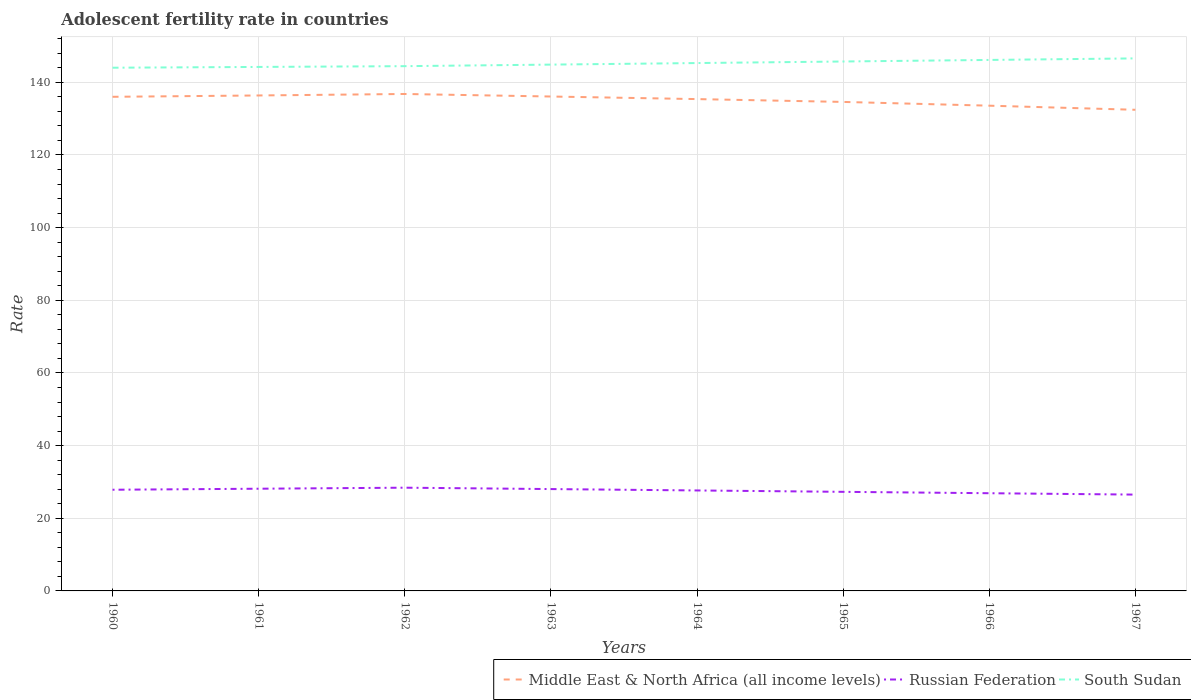How many different coloured lines are there?
Provide a succinct answer. 3. Does the line corresponding to Russian Federation intersect with the line corresponding to South Sudan?
Make the answer very short. No. Across all years, what is the maximum adolescent fertility rate in South Sudan?
Make the answer very short. 144.02. In which year was the adolescent fertility rate in South Sudan maximum?
Provide a short and direct response. 1960. What is the total adolescent fertility rate in Russian Federation in the graph?
Your answer should be compact. 1.52. What is the difference between the highest and the second highest adolescent fertility rate in South Sudan?
Provide a short and direct response. 2.57. What is the difference between the highest and the lowest adolescent fertility rate in South Sudan?
Your answer should be very brief. 4. Is the adolescent fertility rate in Middle East & North Africa (all income levels) strictly greater than the adolescent fertility rate in South Sudan over the years?
Offer a very short reply. Yes. How many lines are there?
Give a very brief answer. 3. What is the difference between two consecutive major ticks on the Y-axis?
Offer a very short reply. 20. Are the values on the major ticks of Y-axis written in scientific E-notation?
Your answer should be compact. No. How many legend labels are there?
Offer a terse response. 3. What is the title of the graph?
Offer a very short reply. Adolescent fertility rate in countries. What is the label or title of the Y-axis?
Offer a very short reply. Rate. What is the Rate of Middle East & North Africa (all income levels) in 1960?
Ensure brevity in your answer.  136.02. What is the Rate of Russian Federation in 1960?
Your answer should be compact. 27.85. What is the Rate in South Sudan in 1960?
Provide a succinct answer. 144.02. What is the Rate of Middle East & North Africa (all income levels) in 1961?
Ensure brevity in your answer.  136.38. What is the Rate in Russian Federation in 1961?
Provide a succinct answer. 28.13. What is the Rate of South Sudan in 1961?
Provide a succinct answer. 144.24. What is the Rate in Middle East & North Africa (all income levels) in 1962?
Your response must be concise. 136.79. What is the Rate of Russian Federation in 1962?
Offer a very short reply. 28.42. What is the Rate in South Sudan in 1962?
Your answer should be compact. 144.45. What is the Rate in Middle East & North Africa (all income levels) in 1963?
Provide a succinct answer. 136.1. What is the Rate of Russian Federation in 1963?
Offer a very short reply. 28.04. What is the Rate in South Sudan in 1963?
Give a very brief answer. 144.88. What is the Rate in Middle East & North Africa (all income levels) in 1964?
Give a very brief answer. 135.38. What is the Rate of Russian Federation in 1964?
Provide a short and direct response. 27.66. What is the Rate of South Sudan in 1964?
Offer a very short reply. 145.31. What is the Rate of Middle East & North Africa (all income levels) in 1965?
Your response must be concise. 134.61. What is the Rate in Russian Federation in 1965?
Keep it short and to the point. 27.28. What is the Rate in South Sudan in 1965?
Offer a very short reply. 145.73. What is the Rate in Middle East & North Africa (all income levels) in 1966?
Provide a short and direct response. 133.57. What is the Rate of Russian Federation in 1966?
Give a very brief answer. 26.89. What is the Rate of South Sudan in 1966?
Your response must be concise. 146.16. What is the Rate of Middle East & North Africa (all income levels) in 1967?
Offer a terse response. 132.44. What is the Rate in Russian Federation in 1967?
Your answer should be very brief. 26.51. What is the Rate of South Sudan in 1967?
Offer a very short reply. 146.59. Across all years, what is the maximum Rate of Middle East & North Africa (all income levels)?
Provide a succinct answer. 136.79. Across all years, what is the maximum Rate of Russian Federation?
Ensure brevity in your answer.  28.42. Across all years, what is the maximum Rate in South Sudan?
Keep it short and to the point. 146.59. Across all years, what is the minimum Rate of Middle East & North Africa (all income levels)?
Your response must be concise. 132.44. Across all years, what is the minimum Rate in Russian Federation?
Ensure brevity in your answer.  26.51. Across all years, what is the minimum Rate in South Sudan?
Give a very brief answer. 144.02. What is the total Rate in Middle East & North Africa (all income levels) in the graph?
Your answer should be compact. 1081.29. What is the total Rate of Russian Federation in the graph?
Make the answer very short. 220.78. What is the total Rate in South Sudan in the graph?
Your answer should be very brief. 1161.38. What is the difference between the Rate in Middle East & North Africa (all income levels) in 1960 and that in 1961?
Give a very brief answer. -0.37. What is the difference between the Rate of Russian Federation in 1960 and that in 1961?
Your answer should be very brief. -0.28. What is the difference between the Rate of South Sudan in 1960 and that in 1961?
Your response must be concise. -0.21. What is the difference between the Rate in Middle East & North Africa (all income levels) in 1960 and that in 1962?
Offer a terse response. -0.78. What is the difference between the Rate of Russian Federation in 1960 and that in 1962?
Provide a succinct answer. -0.57. What is the difference between the Rate of South Sudan in 1960 and that in 1962?
Offer a terse response. -0.43. What is the difference between the Rate of Middle East & North Africa (all income levels) in 1960 and that in 1963?
Give a very brief answer. -0.08. What is the difference between the Rate in Russian Federation in 1960 and that in 1963?
Ensure brevity in your answer.  -0.18. What is the difference between the Rate of South Sudan in 1960 and that in 1963?
Your answer should be compact. -0.86. What is the difference between the Rate of Middle East & North Africa (all income levels) in 1960 and that in 1964?
Your response must be concise. 0.63. What is the difference between the Rate of Russian Federation in 1960 and that in 1964?
Your response must be concise. 0.2. What is the difference between the Rate of South Sudan in 1960 and that in 1964?
Provide a succinct answer. -1.28. What is the difference between the Rate of Middle East & North Africa (all income levels) in 1960 and that in 1965?
Provide a short and direct response. 1.41. What is the difference between the Rate of Russian Federation in 1960 and that in 1965?
Provide a short and direct response. 0.58. What is the difference between the Rate in South Sudan in 1960 and that in 1965?
Offer a very short reply. -1.71. What is the difference between the Rate of Middle East & North Africa (all income levels) in 1960 and that in 1966?
Provide a short and direct response. 2.44. What is the difference between the Rate in Russian Federation in 1960 and that in 1966?
Ensure brevity in your answer.  0.96. What is the difference between the Rate in South Sudan in 1960 and that in 1966?
Your answer should be very brief. -2.14. What is the difference between the Rate of Middle East & North Africa (all income levels) in 1960 and that in 1967?
Provide a succinct answer. 3.58. What is the difference between the Rate of Russian Federation in 1960 and that in 1967?
Ensure brevity in your answer.  1.34. What is the difference between the Rate in South Sudan in 1960 and that in 1967?
Provide a succinct answer. -2.57. What is the difference between the Rate in Middle East & North Africa (all income levels) in 1961 and that in 1962?
Your answer should be very brief. -0.41. What is the difference between the Rate of Russian Federation in 1961 and that in 1962?
Give a very brief answer. -0.28. What is the difference between the Rate in South Sudan in 1961 and that in 1962?
Ensure brevity in your answer.  -0.21. What is the difference between the Rate in Middle East & North Africa (all income levels) in 1961 and that in 1963?
Give a very brief answer. 0.29. What is the difference between the Rate of Russian Federation in 1961 and that in 1963?
Make the answer very short. 0.1. What is the difference between the Rate of South Sudan in 1961 and that in 1963?
Your answer should be very brief. -0.64. What is the difference between the Rate in Russian Federation in 1961 and that in 1964?
Keep it short and to the point. 0.48. What is the difference between the Rate in South Sudan in 1961 and that in 1964?
Offer a terse response. -1.07. What is the difference between the Rate of Middle East & North Africa (all income levels) in 1961 and that in 1965?
Make the answer very short. 1.78. What is the difference between the Rate of Russian Federation in 1961 and that in 1965?
Your response must be concise. 0.86. What is the difference between the Rate of South Sudan in 1961 and that in 1965?
Your response must be concise. -1.5. What is the difference between the Rate of Middle East & North Africa (all income levels) in 1961 and that in 1966?
Offer a terse response. 2.81. What is the difference between the Rate of Russian Federation in 1961 and that in 1966?
Offer a very short reply. 1.24. What is the difference between the Rate in South Sudan in 1961 and that in 1966?
Your answer should be compact. -1.93. What is the difference between the Rate in Middle East & North Africa (all income levels) in 1961 and that in 1967?
Give a very brief answer. 3.94. What is the difference between the Rate in Russian Federation in 1961 and that in 1967?
Give a very brief answer. 1.62. What is the difference between the Rate in South Sudan in 1961 and that in 1967?
Keep it short and to the point. -2.35. What is the difference between the Rate of Middle East & North Africa (all income levels) in 1962 and that in 1963?
Offer a very short reply. 0.7. What is the difference between the Rate in Russian Federation in 1962 and that in 1963?
Make the answer very short. 0.38. What is the difference between the Rate in South Sudan in 1962 and that in 1963?
Keep it short and to the point. -0.43. What is the difference between the Rate of Middle East & North Africa (all income levels) in 1962 and that in 1964?
Your response must be concise. 1.41. What is the difference between the Rate of Russian Federation in 1962 and that in 1964?
Ensure brevity in your answer.  0.76. What is the difference between the Rate of South Sudan in 1962 and that in 1964?
Your answer should be very brief. -0.86. What is the difference between the Rate of Middle East & North Africa (all income levels) in 1962 and that in 1965?
Give a very brief answer. 2.18. What is the difference between the Rate in Russian Federation in 1962 and that in 1965?
Make the answer very short. 1.14. What is the difference between the Rate in South Sudan in 1962 and that in 1965?
Offer a terse response. -1.28. What is the difference between the Rate of Middle East & North Africa (all income levels) in 1962 and that in 1966?
Keep it short and to the point. 3.22. What is the difference between the Rate in Russian Federation in 1962 and that in 1966?
Give a very brief answer. 1.52. What is the difference between the Rate of South Sudan in 1962 and that in 1966?
Keep it short and to the point. -1.71. What is the difference between the Rate of Middle East & North Africa (all income levels) in 1962 and that in 1967?
Your response must be concise. 4.35. What is the difference between the Rate of Russian Federation in 1962 and that in 1967?
Provide a short and direct response. 1.9. What is the difference between the Rate of South Sudan in 1962 and that in 1967?
Provide a short and direct response. -2.14. What is the difference between the Rate in Middle East & North Africa (all income levels) in 1963 and that in 1964?
Ensure brevity in your answer.  0.71. What is the difference between the Rate of Russian Federation in 1963 and that in 1964?
Offer a terse response. 0.38. What is the difference between the Rate of South Sudan in 1963 and that in 1964?
Your answer should be compact. -0.43. What is the difference between the Rate in Middle East & North Africa (all income levels) in 1963 and that in 1965?
Your response must be concise. 1.49. What is the difference between the Rate of Russian Federation in 1963 and that in 1965?
Offer a terse response. 0.76. What is the difference between the Rate in South Sudan in 1963 and that in 1965?
Offer a very short reply. -0.86. What is the difference between the Rate of Middle East & North Africa (all income levels) in 1963 and that in 1966?
Your answer should be very brief. 2.52. What is the difference between the Rate of Russian Federation in 1963 and that in 1966?
Your answer should be very brief. 1.14. What is the difference between the Rate of South Sudan in 1963 and that in 1966?
Provide a succinct answer. -1.28. What is the difference between the Rate of Middle East & North Africa (all income levels) in 1963 and that in 1967?
Offer a very short reply. 3.65. What is the difference between the Rate of Russian Federation in 1963 and that in 1967?
Your response must be concise. 1.52. What is the difference between the Rate of South Sudan in 1963 and that in 1967?
Provide a short and direct response. -1.71. What is the difference between the Rate in Middle East & North Africa (all income levels) in 1964 and that in 1965?
Provide a succinct answer. 0.78. What is the difference between the Rate in Russian Federation in 1964 and that in 1965?
Make the answer very short. 0.38. What is the difference between the Rate in South Sudan in 1964 and that in 1965?
Your response must be concise. -0.43. What is the difference between the Rate of Middle East & North Africa (all income levels) in 1964 and that in 1966?
Give a very brief answer. 1.81. What is the difference between the Rate in Russian Federation in 1964 and that in 1966?
Your response must be concise. 0.76. What is the difference between the Rate of South Sudan in 1964 and that in 1966?
Ensure brevity in your answer.  -0.86. What is the difference between the Rate of Middle East & North Africa (all income levels) in 1964 and that in 1967?
Your answer should be very brief. 2.94. What is the difference between the Rate in Russian Federation in 1964 and that in 1967?
Provide a short and direct response. 1.14. What is the difference between the Rate in South Sudan in 1964 and that in 1967?
Provide a short and direct response. -1.28. What is the difference between the Rate in Middle East & North Africa (all income levels) in 1965 and that in 1966?
Keep it short and to the point. 1.04. What is the difference between the Rate of Russian Federation in 1965 and that in 1966?
Offer a very short reply. 0.38. What is the difference between the Rate in South Sudan in 1965 and that in 1966?
Your answer should be very brief. -0.43. What is the difference between the Rate of Middle East & North Africa (all income levels) in 1965 and that in 1967?
Offer a terse response. 2.17. What is the difference between the Rate of Russian Federation in 1965 and that in 1967?
Make the answer very short. 0.76. What is the difference between the Rate in South Sudan in 1965 and that in 1967?
Offer a very short reply. -0.86. What is the difference between the Rate of Middle East & North Africa (all income levels) in 1966 and that in 1967?
Your answer should be compact. 1.13. What is the difference between the Rate of Russian Federation in 1966 and that in 1967?
Your response must be concise. 0.38. What is the difference between the Rate of South Sudan in 1966 and that in 1967?
Your answer should be compact. -0.43. What is the difference between the Rate in Middle East & North Africa (all income levels) in 1960 and the Rate in Russian Federation in 1961?
Your answer should be very brief. 107.88. What is the difference between the Rate in Middle East & North Africa (all income levels) in 1960 and the Rate in South Sudan in 1961?
Your answer should be very brief. -8.22. What is the difference between the Rate in Russian Federation in 1960 and the Rate in South Sudan in 1961?
Ensure brevity in your answer.  -116.38. What is the difference between the Rate in Middle East & North Africa (all income levels) in 1960 and the Rate in Russian Federation in 1962?
Your answer should be compact. 107.6. What is the difference between the Rate in Middle East & North Africa (all income levels) in 1960 and the Rate in South Sudan in 1962?
Offer a very short reply. -8.43. What is the difference between the Rate of Russian Federation in 1960 and the Rate of South Sudan in 1962?
Give a very brief answer. -116.6. What is the difference between the Rate in Middle East & North Africa (all income levels) in 1960 and the Rate in Russian Federation in 1963?
Offer a very short reply. 107.98. What is the difference between the Rate in Middle East & North Africa (all income levels) in 1960 and the Rate in South Sudan in 1963?
Provide a short and direct response. -8.86. What is the difference between the Rate in Russian Federation in 1960 and the Rate in South Sudan in 1963?
Ensure brevity in your answer.  -117.03. What is the difference between the Rate in Middle East & North Africa (all income levels) in 1960 and the Rate in Russian Federation in 1964?
Offer a very short reply. 108.36. What is the difference between the Rate of Middle East & North Africa (all income levels) in 1960 and the Rate of South Sudan in 1964?
Offer a very short reply. -9.29. What is the difference between the Rate in Russian Federation in 1960 and the Rate in South Sudan in 1964?
Provide a succinct answer. -117.45. What is the difference between the Rate in Middle East & North Africa (all income levels) in 1960 and the Rate in Russian Federation in 1965?
Offer a very short reply. 108.74. What is the difference between the Rate in Middle East & North Africa (all income levels) in 1960 and the Rate in South Sudan in 1965?
Keep it short and to the point. -9.72. What is the difference between the Rate in Russian Federation in 1960 and the Rate in South Sudan in 1965?
Provide a short and direct response. -117.88. What is the difference between the Rate in Middle East & North Africa (all income levels) in 1960 and the Rate in Russian Federation in 1966?
Give a very brief answer. 109.12. What is the difference between the Rate of Middle East & North Africa (all income levels) in 1960 and the Rate of South Sudan in 1966?
Keep it short and to the point. -10.15. What is the difference between the Rate in Russian Federation in 1960 and the Rate in South Sudan in 1966?
Offer a terse response. -118.31. What is the difference between the Rate in Middle East & North Africa (all income levels) in 1960 and the Rate in Russian Federation in 1967?
Provide a short and direct response. 109.5. What is the difference between the Rate in Middle East & North Africa (all income levels) in 1960 and the Rate in South Sudan in 1967?
Keep it short and to the point. -10.57. What is the difference between the Rate of Russian Federation in 1960 and the Rate of South Sudan in 1967?
Make the answer very short. -118.74. What is the difference between the Rate of Middle East & North Africa (all income levels) in 1961 and the Rate of Russian Federation in 1962?
Make the answer very short. 107.97. What is the difference between the Rate in Middle East & North Africa (all income levels) in 1961 and the Rate in South Sudan in 1962?
Keep it short and to the point. -8.07. What is the difference between the Rate in Russian Federation in 1961 and the Rate in South Sudan in 1962?
Give a very brief answer. -116.32. What is the difference between the Rate of Middle East & North Africa (all income levels) in 1961 and the Rate of Russian Federation in 1963?
Your answer should be very brief. 108.35. What is the difference between the Rate in Middle East & North Africa (all income levels) in 1961 and the Rate in South Sudan in 1963?
Provide a short and direct response. -8.49. What is the difference between the Rate in Russian Federation in 1961 and the Rate in South Sudan in 1963?
Your answer should be compact. -116.74. What is the difference between the Rate of Middle East & North Africa (all income levels) in 1961 and the Rate of Russian Federation in 1964?
Offer a very short reply. 108.73. What is the difference between the Rate in Middle East & North Africa (all income levels) in 1961 and the Rate in South Sudan in 1964?
Make the answer very short. -8.92. What is the difference between the Rate of Russian Federation in 1961 and the Rate of South Sudan in 1964?
Give a very brief answer. -117.17. What is the difference between the Rate of Middle East & North Africa (all income levels) in 1961 and the Rate of Russian Federation in 1965?
Keep it short and to the point. 109.11. What is the difference between the Rate of Middle East & North Africa (all income levels) in 1961 and the Rate of South Sudan in 1965?
Your answer should be very brief. -9.35. What is the difference between the Rate of Russian Federation in 1961 and the Rate of South Sudan in 1965?
Offer a terse response. -117.6. What is the difference between the Rate of Middle East & North Africa (all income levels) in 1961 and the Rate of Russian Federation in 1966?
Provide a short and direct response. 109.49. What is the difference between the Rate of Middle East & North Africa (all income levels) in 1961 and the Rate of South Sudan in 1966?
Keep it short and to the point. -9.78. What is the difference between the Rate of Russian Federation in 1961 and the Rate of South Sudan in 1966?
Your answer should be compact. -118.03. What is the difference between the Rate of Middle East & North Africa (all income levels) in 1961 and the Rate of Russian Federation in 1967?
Make the answer very short. 109.87. What is the difference between the Rate in Middle East & North Africa (all income levels) in 1961 and the Rate in South Sudan in 1967?
Make the answer very short. -10.21. What is the difference between the Rate in Russian Federation in 1961 and the Rate in South Sudan in 1967?
Keep it short and to the point. -118.46. What is the difference between the Rate in Middle East & North Africa (all income levels) in 1962 and the Rate in Russian Federation in 1963?
Keep it short and to the point. 108.76. What is the difference between the Rate in Middle East & North Africa (all income levels) in 1962 and the Rate in South Sudan in 1963?
Provide a short and direct response. -8.09. What is the difference between the Rate in Russian Federation in 1962 and the Rate in South Sudan in 1963?
Ensure brevity in your answer.  -116.46. What is the difference between the Rate of Middle East & North Africa (all income levels) in 1962 and the Rate of Russian Federation in 1964?
Provide a succinct answer. 109.14. What is the difference between the Rate of Middle East & North Africa (all income levels) in 1962 and the Rate of South Sudan in 1964?
Your answer should be compact. -8.51. What is the difference between the Rate of Russian Federation in 1962 and the Rate of South Sudan in 1964?
Make the answer very short. -116.89. What is the difference between the Rate of Middle East & North Africa (all income levels) in 1962 and the Rate of Russian Federation in 1965?
Give a very brief answer. 109.52. What is the difference between the Rate in Middle East & North Africa (all income levels) in 1962 and the Rate in South Sudan in 1965?
Your answer should be compact. -8.94. What is the difference between the Rate in Russian Federation in 1962 and the Rate in South Sudan in 1965?
Offer a terse response. -117.32. What is the difference between the Rate of Middle East & North Africa (all income levels) in 1962 and the Rate of Russian Federation in 1966?
Provide a short and direct response. 109.9. What is the difference between the Rate in Middle East & North Africa (all income levels) in 1962 and the Rate in South Sudan in 1966?
Make the answer very short. -9.37. What is the difference between the Rate in Russian Federation in 1962 and the Rate in South Sudan in 1966?
Your answer should be very brief. -117.75. What is the difference between the Rate in Middle East & North Africa (all income levels) in 1962 and the Rate in Russian Federation in 1967?
Give a very brief answer. 110.28. What is the difference between the Rate in Middle East & North Africa (all income levels) in 1962 and the Rate in South Sudan in 1967?
Offer a terse response. -9.8. What is the difference between the Rate in Russian Federation in 1962 and the Rate in South Sudan in 1967?
Your answer should be very brief. -118.17. What is the difference between the Rate of Middle East & North Africa (all income levels) in 1963 and the Rate of Russian Federation in 1964?
Your response must be concise. 108.44. What is the difference between the Rate in Middle East & North Africa (all income levels) in 1963 and the Rate in South Sudan in 1964?
Give a very brief answer. -9.21. What is the difference between the Rate of Russian Federation in 1963 and the Rate of South Sudan in 1964?
Offer a terse response. -117.27. What is the difference between the Rate of Middle East & North Africa (all income levels) in 1963 and the Rate of Russian Federation in 1965?
Keep it short and to the point. 108.82. What is the difference between the Rate in Middle East & North Africa (all income levels) in 1963 and the Rate in South Sudan in 1965?
Your answer should be very brief. -9.64. What is the difference between the Rate in Russian Federation in 1963 and the Rate in South Sudan in 1965?
Your answer should be compact. -117.7. What is the difference between the Rate of Middle East & North Africa (all income levels) in 1963 and the Rate of Russian Federation in 1966?
Your answer should be very brief. 109.2. What is the difference between the Rate of Middle East & North Africa (all income levels) in 1963 and the Rate of South Sudan in 1966?
Provide a succinct answer. -10.07. What is the difference between the Rate in Russian Federation in 1963 and the Rate in South Sudan in 1966?
Ensure brevity in your answer.  -118.13. What is the difference between the Rate of Middle East & North Africa (all income levels) in 1963 and the Rate of Russian Federation in 1967?
Keep it short and to the point. 109.58. What is the difference between the Rate of Middle East & North Africa (all income levels) in 1963 and the Rate of South Sudan in 1967?
Your answer should be very brief. -10.49. What is the difference between the Rate of Russian Federation in 1963 and the Rate of South Sudan in 1967?
Keep it short and to the point. -118.55. What is the difference between the Rate in Middle East & North Africa (all income levels) in 1964 and the Rate in Russian Federation in 1965?
Offer a very short reply. 108.11. What is the difference between the Rate in Middle East & North Africa (all income levels) in 1964 and the Rate in South Sudan in 1965?
Provide a short and direct response. -10.35. What is the difference between the Rate of Russian Federation in 1964 and the Rate of South Sudan in 1965?
Offer a terse response. -118.08. What is the difference between the Rate of Middle East & North Africa (all income levels) in 1964 and the Rate of Russian Federation in 1966?
Your answer should be very brief. 108.49. What is the difference between the Rate in Middle East & North Africa (all income levels) in 1964 and the Rate in South Sudan in 1966?
Give a very brief answer. -10.78. What is the difference between the Rate in Russian Federation in 1964 and the Rate in South Sudan in 1966?
Your answer should be very brief. -118.51. What is the difference between the Rate of Middle East & North Africa (all income levels) in 1964 and the Rate of Russian Federation in 1967?
Ensure brevity in your answer.  108.87. What is the difference between the Rate of Middle East & North Africa (all income levels) in 1964 and the Rate of South Sudan in 1967?
Keep it short and to the point. -11.21. What is the difference between the Rate in Russian Federation in 1964 and the Rate in South Sudan in 1967?
Offer a terse response. -118.93. What is the difference between the Rate in Middle East & North Africa (all income levels) in 1965 and the Rate in Russian Federation in 1966?
Offer a terse response. 107.71. What is the difference between the Rate in Middle East & North Africa (all income levels) in 1965 and the Rate in South Sudan in 1966?
Keep it short and to the point. -11.55. What is the difference between the Rate in Russian Federation in 1965 and the Rate in South Sudan in 1966?
Ensure brevity in your answer.  -118.89. What is the difference between the Rate in Middle East & North Africa (all income levels) in 1965 and the Rate in Russian Federation in 1967?
Make the answer very short. 108.09. What is the difference between the Rate of Middle East & North Africa (all income levels) in 1965 and the Rate of South Sudan in 1967?
Ensure brevity in your answer.  -11.98. What is the difference between the Rate in Russian Federation in 1965 and the Rate in South Sudan in 1967?
Provide a short and direct response. -119.31. What is the difference between the Rate in Middle East & North Africa (all income levels) in 1966 and the Rate in Russian Federation in 1967?
Your answer should be compact. 107.06. What is the difference between the Rate of Middle East & North Africa (all income levels) in 1966 and the Rate of South Sudan in 1967?
Your answer should be very brief. -13.02. What is the difference between the Rate in Russian Federation in 1966 and the Rate in South Sudan in 1967?
Your answer should be compact. -119.7. What is the average Rate in Middle East & North Africa (all income levels) per year?
Offer a terse response. 135.16. What is the average Rate in Russian Federation per year?
Ensure brevity in your answer.  27.6. What is the average Rate of South Sudan per year?
Provide a succinct answer. 145.17. In the year 1960, what is the difference between the Rate of Middle East & North Africa (all income levels) and Rate of Russian Federation?
Provide a short and direct response. 108.16. In the year 1960, what is the difference between the Rate in Middle East & North Africa (all income levels) and Rate in South Sudan?
Provide a succinct answer. -8.01. In the year 1960, what is the difference between the Rate in Russian Federation and Rate in South Sudan?
Ensure brevity in your answer.  -116.17. In the year 1961, what is the difference between the Rate in Middle East & North Africa (all income levels) and Rate in Russian Federation?
Your answer should be compact. 108.25. In the year 1961, what is the difference between the Rate in Middle East & North Africa (all income levels) and Rate in South Sudan?
Make the answer very short. -7.85. In the year 1961, what is the difference between the Rate in Russian Federation and Rate in South Sudan?
Provide a short and direct response. -116.1. In the year 1962, what is the difference between the Rate of Middle East & North Africa (all income levels) and Rate of Russian Federation?
Ensure brevity in your answer.  108.38. In the year 1962, what is the difference between the Rate of Middle East & North Africa (all income levels) and Rate of South Sudan?
Offer a very short reply. -7.66. In the year 1962, what is the difference between the Rate of Russian Federation and Rate of South Sudan?
Offer a very short reply. -116.03. In the year 1963, what is the difference between the Rate in Middle East & North Africa (all income levels) and Rate in Russian Federation?
Your answer should be very brief. 108.06. In the year 1963, what is the difference between the Rate of Middle East & North Africa (all income levels) and Rate of South Sudan?
Make the answer very short. -8.78. In the year 1963, what is the difference between the Rate of Russian Federation and Rate of South Sudan?
Your response must be concise. -116.84. In the year 1964, what is the difference between the Rate of Middle East & North Africa (all income levels) and Rate of Russian Federation?
Your response must be concise. 107.73. In the year 1964, what is the difference between the Rate of Middle East & North Africa (all income levels) and Rate of South Sudan?
Your answer should be very brief. -9.92. In the year 1964, what is the difference between the Rate in Russian Federation and Rate in South Sudan?
Give a very brief answer. -117.65. In the year 1965, what is the difference between the Rate of Middle East & North Africa (all income levels) and Rate of Russian Federation?
Offer a very short reply. 107.33. In the year 1965, what is the difference between the Rate of Middle East & North Africa (all income levels) and Rate of South Sudan?
Provide a succinct answer. -11.13. In the year 1965, what is the difference between the Rate of Russian Federation and Rate of South Sudan?
Give a very brief answer. -118.46. In the year 1966, what is the difference between the Rate of Middle East & North Africa (all income levels) and Rate of Russian Federation?
Your answer should be very brief. 106.68. In the year 1966, what is the difference between the Rate of Middle East & North Africa (all income levels) and Rate of South Sudan?
Provide a short and direct response. -12.59. In the year 1966, what is the difference between the Rate of Russian Federation and Rate of South Sudan?
Offer a terse response. -119.27. In the year 1967, what is the difference between the Rate of Middle East & North Africa (all income levels) and Rate of Russian Federation?
Your answer should be very brief. 105.93. In the year 1967, what is the difference between the Rate of Middle East & North Africa (all income levels) and Rate of South Sudan?
Your response must be concise. -14.15. In the year 1967, what is the difference between the Rate in Russian Federation and Rate in South Sudan?
Offer a very short reply. -120.08. What is the ratio of the Rate in Russian Federation in 1960 to that in 1961?
Your answer should be compact. 0.99. What is the ratio of the Rate of Russian Federation in 1960 to that in 1962?
Your answer should be compact. 0.98. What is the ratio of the Rate in South Sudan in 1960 to that in 1962?
Keep it short and to the point. 1. What is the ratio of the Rate in Russian Federation in 1960 to that in 1963?
Make the answer very short. 0.99. What is the ratio of the Rate of South Sudan in 1960 to that in 1963?
Provide a succinct answer. 0.99. What is the ratio of the Rate of Russian Federation in 1960 to that in 1964?
Your response must be concise. 1.01. What is the ratio of the Rate in South Sudan in 1960 to that in 1964?
Provide a succinct answer. 0.99. What is the ratio of the Rate in Middle East & North Africa (all income levels) in 1960 to that in 1965?
Give a very brief answer. 1.01. What is the ratio of the Rate of Russian Federation in 1960 to that in 1965?
Your response must be concise. 1.02. What is the ratio of the Rate in South Sudan in 1960 to that in 1965?
Your response must be concise. 0.99. What is the ratio of the Rate of Middle East & North Africa (all income levels) in 1960 to that in 1966?
Give a very brief answer. 1.02. What is the ratio of the Rate in Russian Federation in 1960 to that in 1966?
Your answer should be compact. 1.04. What is the ratio of the Rate of South Sudan in 1960 to that in 1966?
Offer a very short reply. 0.99. What is the ratio of the Rate in Russian Federation in 1960 to that in 1967?
Your answer should be very brief. 1.05. What is the ratio of the Rate of South Sudan in 1960 to that in 1967?
Keep it short and to the point. 0.98. What is the ratio of the Rate of Middle East & North Africa (all income levels) in 1961 to that in 1962?
Keep it short and to the point. 1. What is the ratio of the Rate in Russian Federation in 1961 to that in 1963?
Your answer should be compact. 1. What is the ratio of the Rate of South Sudan in 1961 to that in 1963?
Provide a succinct answer. 1. What is the ratio of the Rate of Middle East & North Africa (all income levels) in 1961 to that in 1964?
Your answer should be very brief. 1.01. What is the ratio of the Rate in Russian Federation in 1961 to that in 1964?
Your answer should be very brief. 1.02. What is the ratio of the Rate in South Sudan in 1961 to that in 1964?
Make the answer very short. 0.99. What is the ratio of the Rate in Middle East & North Africa (all income levels) in 1961 to that in 1965?
Make the answer very short. 1.01. What is the ratio of the Rate of Russian Federation in 1961 to that in 1965?
Your answer should be very brief. 1.03. What is the ratio of the Rate of Middle East & North Africa (all income levels) in 1961 to that in 1966?
Provide a short and direct response. 1.02. What is the ratio of the Rate of Russian Federation in 1961 to that in 1966?
Provide a succinct answer. 1.05. What is the ratio of the Rate in South Sudan in 1961 to that in 1966?
Offer a very short reply. 0.99. What is the ratio of the Rate of Middle East & North Africa (all income levels) in 1961 to that in 1967?
Your answer should be compact. 1.03. What is the ratio of the Rate in Russian Federation in 1961 to that in 1967?
Your answer should be compact. 1.06. What is the ratio of the Rate in South Sudan in 1961 to that in 1967?
Ensure brevity in your answer.  0.98. What is the ratio of the Rate in Middle East & North Africa (all income levels) in 1962 to that in 1963?
Keep it short and to the point. 1.01. What is the ratio of the Rate of Russian Federation in 1962 to that in 1963?
Ensure brevity in your answer.  1.01. What is the ratio of the Rate of Middle East & North Africa (all income levels) in 1962 to that in 1964?
Keep it short and to the point. 1.01. What is the ratio of the Rate in Russian Federation in 1962 to that in 1964?
Provide a short and direct response. 1.03. What is the ratio of the Rate in South Sudan in 1962 to that in 1964?
Provide a succinct answer. 0.99. What is the ratio of the Rate in Middle East & North Africa (all income levels) in 1962 to that in 1965?
Your answer should be compact. 1.02. What is the ratio of the Rate of Russian Federation in 1962 to that in 1965?
Your response must be concise. 1.04. What is the ratio of the Rate in Middle East & North Africa (all income levels) in 1962 to that in 1966?
Make the answer very short. 1.02. What is the ratio of the Rate of Russian Federation in 1962 to that in 1966?
Your answer should be very brief. 1.06. What is the ratio of the Rate in South Sudan in 1962 to that in 1966?
Keep it short and to the point. 0.99. What is the ratio of the Rate of Middle East & North Africa (all income levels) in 1962 to that in 1967?
Keep it short and to the point. 1.03. What is the ratio of the Rate of Russian Federation in 1962 to that in 1967?
Offer a very short reply. 1.07. What is the ratio of the Rate of South Sudan in 1962 to that in 1967?
Your answer should be very brief. 0.99. What is the ratio of the Rate in Russian Federation in 1963 to that in 1964?
Your response must be concise. 1.01. What is the ratio of the Rate in Middle East & North Africa (all income levels) in 1963 to that in 1965?
Your answer should be compact. 1.01. What is the ratio of the Rate of Russian Federation in 1963 to that in 1965?
Give a very brief answer. 1.03. What is the ratio of the Rate in Middle East & North Africa (all income levels) in 1963 to that in 1966?
Provide a short and direct response. 1.02. What is the ratio of the Rate in Russian Federation in 1963 to that in 1966?
Give a very brief answer. 1.04. What is the ratio of the Rate of South Sudan in 1963 to that in 1966?
Keep it short and to the point. 0.99. What is the ratio of the Rate in Middle East & North Africa (all income levels) in 1963 to that in 1967?
Provide a short and direct response. 1.03. What is the ratio of the Rate of Russian Federation in 1963 to that in 1967?
Keep it short and to the point. 1.06. What is the ratio of the Rate of South Sudan in 1963 to that in 1967?
Make the answer very short. 0.99. What is the ratio of the Rate in Russian Federation in 1964 to that in 1965?
Your answer should be compact. 1.01. What is the ratio of the Rate of South Sudan in 1964 to that in 1965?
Provide a succinct answer. 1. What is the ratio of the Rate in Middle East & North Africa (all income levels) in 1964 to that in 1966?
Your answer should be very brief. 1.01. What is the ratio of the Rate of Russian Federation in 1964 to that in 1966?
Your answer should be compact. 1.03. What is the ratio of the Rate in Middle East & North Africa (all income levels) in 1964 to that in 1967?
Keep it short and to the point. 1.02. What is the ratio of the Rate of Russian Federation in 1964 to that in 1967?
Keep it short and to the point. 1.04. What is the ratio of the Rate in Middle East & North Africa (all income levels) in 1965 to that in 1966?
Offer a very short reply. 1.01. What is the ratio of the Rate of Russian Federation in 1965 to that in 1966?
Your response must be concise. 1.01. What is the ratio of the Rate in Middle East & North Africa (all income levels) in 1965 to that in 1967?
Your response must be concise. 1.02. What is the ratio of the Rate of Russian Federation in 1965 to that in 1967?
Your answer should be compact. 1.03. What is the ratio of the Rate in South Sudan in 1965 to that in 1967?
Make the answer very short. 0.99. What is the ratio of the Rate in Middle East & North Africa (all income levels) in 1966 to that in 1967?
Ensure brevity in your answer.  1.01. What is the ratio of the Rate in Russian Federation in 1966 to that in 1967?
Make the answer very short. 1.01. What is the ratio of the Rate in South Sudan in 1966 to that in 1967?
Your answer should be very brief. 1. What is the difference between the highest and the second highest Rate in Middle East & North Africa (all income levels)?
Ensure brevity in your answer.  0.41. What is the difference between the highest and the second highest Rate of Russian Federation?
Your answer should be compact. 0.28. What is the difference between the highest and the second highest Rate in South Sudan?
Provide a succinct answer. 0.43. What is the difference between the highest and the lowest Rate in Middle East & North Africa (all income levels)?
Offer a terse response. 4.35. What is the difference between the highest and the lowest Rate of Russian Federation?
Offer a very short reply. 1.9. What is the difference between the highest and the lowest Rate in South Sudan?
Your answer should be very brief. 2.57. 